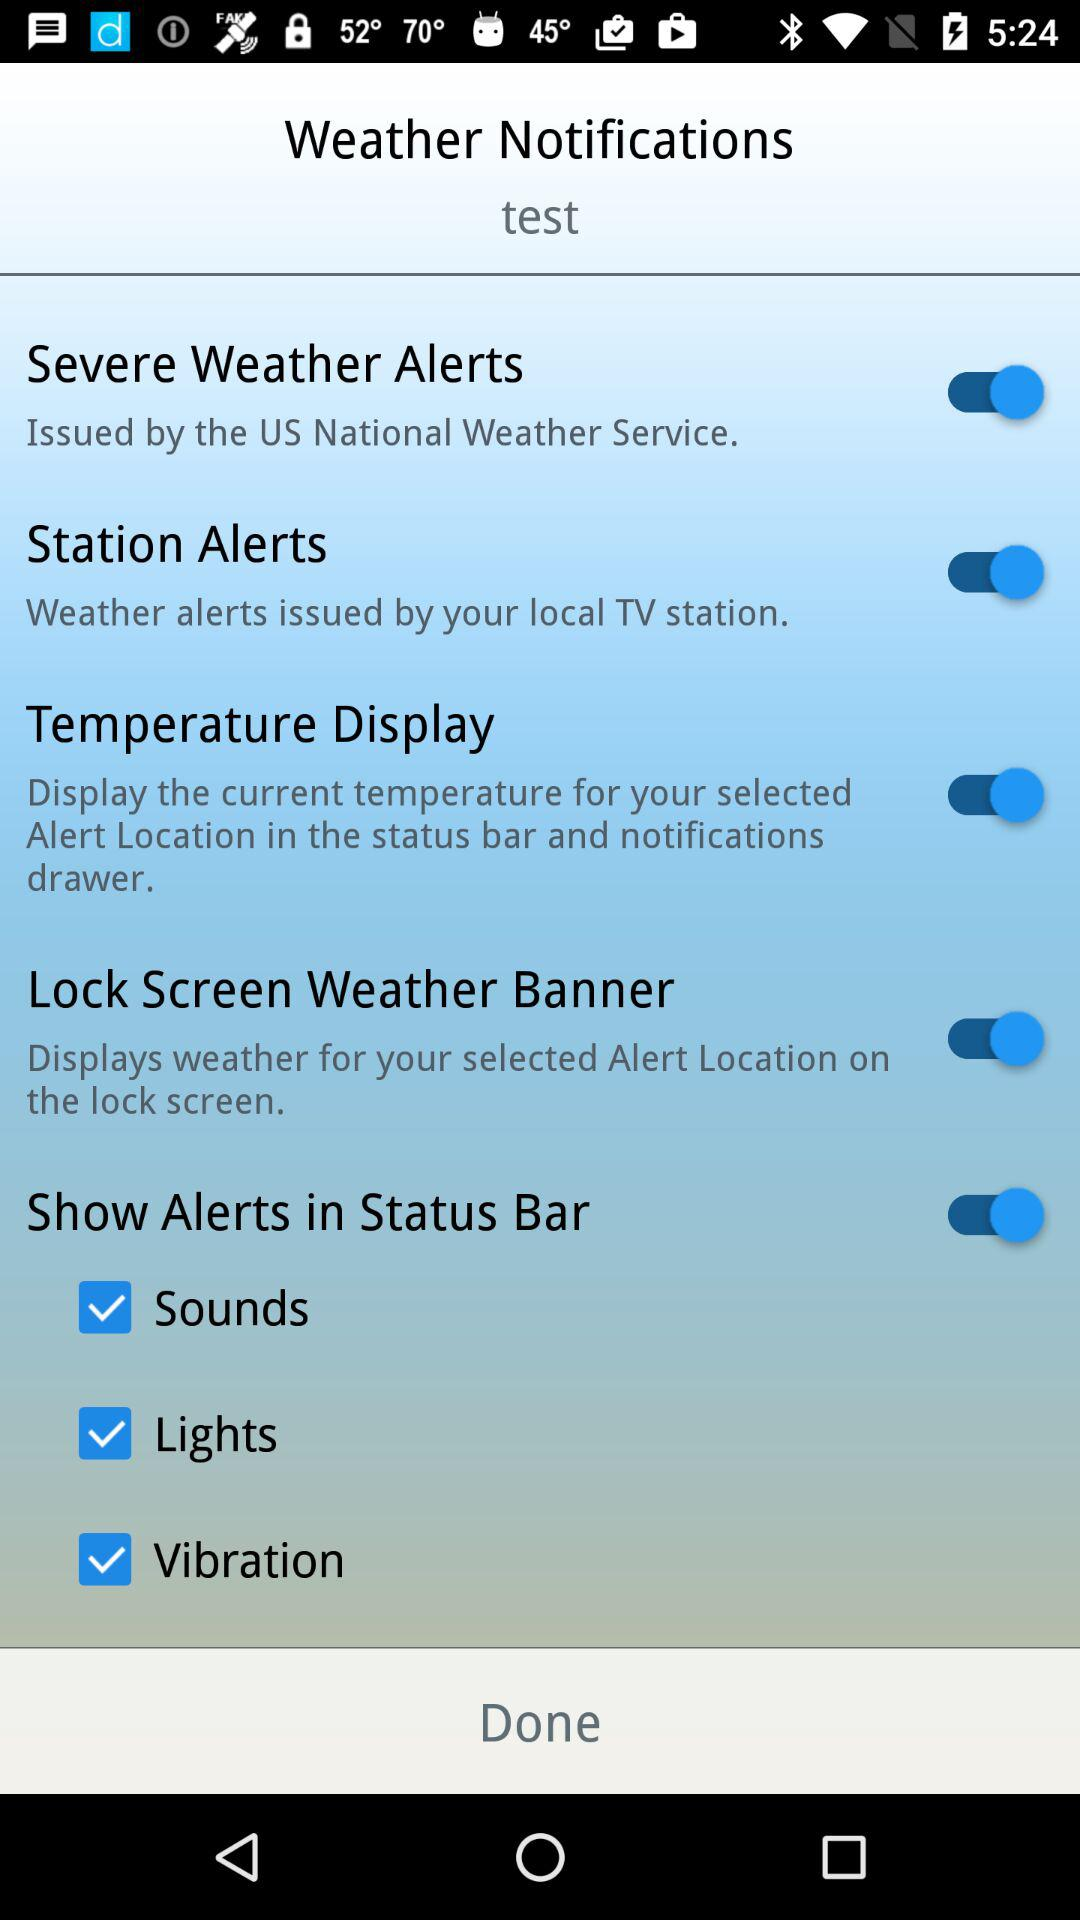What is the status of the "Lock Screen Weather Banner"? The status of the "Lock Screen Weather Banner" is "on". 